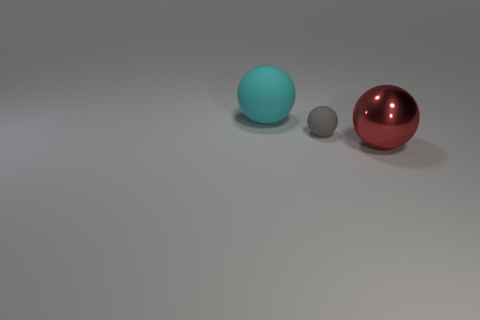Subtract all gray rubber balls. How many balls are left? 2 Subtract all cyan spheres. How many spheres are left? 2 Add 3 tiny blue rubber objects. How many objects exist? 6 Subtract 1 spheres. How many spheres are left? 2 Add 3 big rubber balls. How many big rubber balls are left? 4 Add 2 tiny gray matte things. How many tiny gray matte things exist? 3 Subtract 0 blue balls. How many objects are left? 3 Subtract all cyan balls. Subtract all yellow cubes. How many balls are left? 2 Subtract all large cyan balls. Subtract all brown shiny cylinders. How many objects are left? 2 